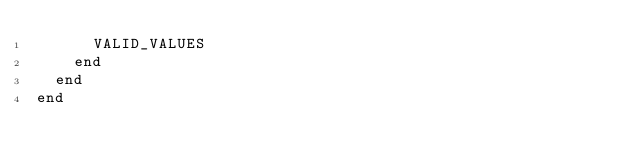Convert code to text. <code><loc_0><loc_0><loc_500><loc_500><_Ruby_>      VALID_VALUES
    end
  end
end
</code> 